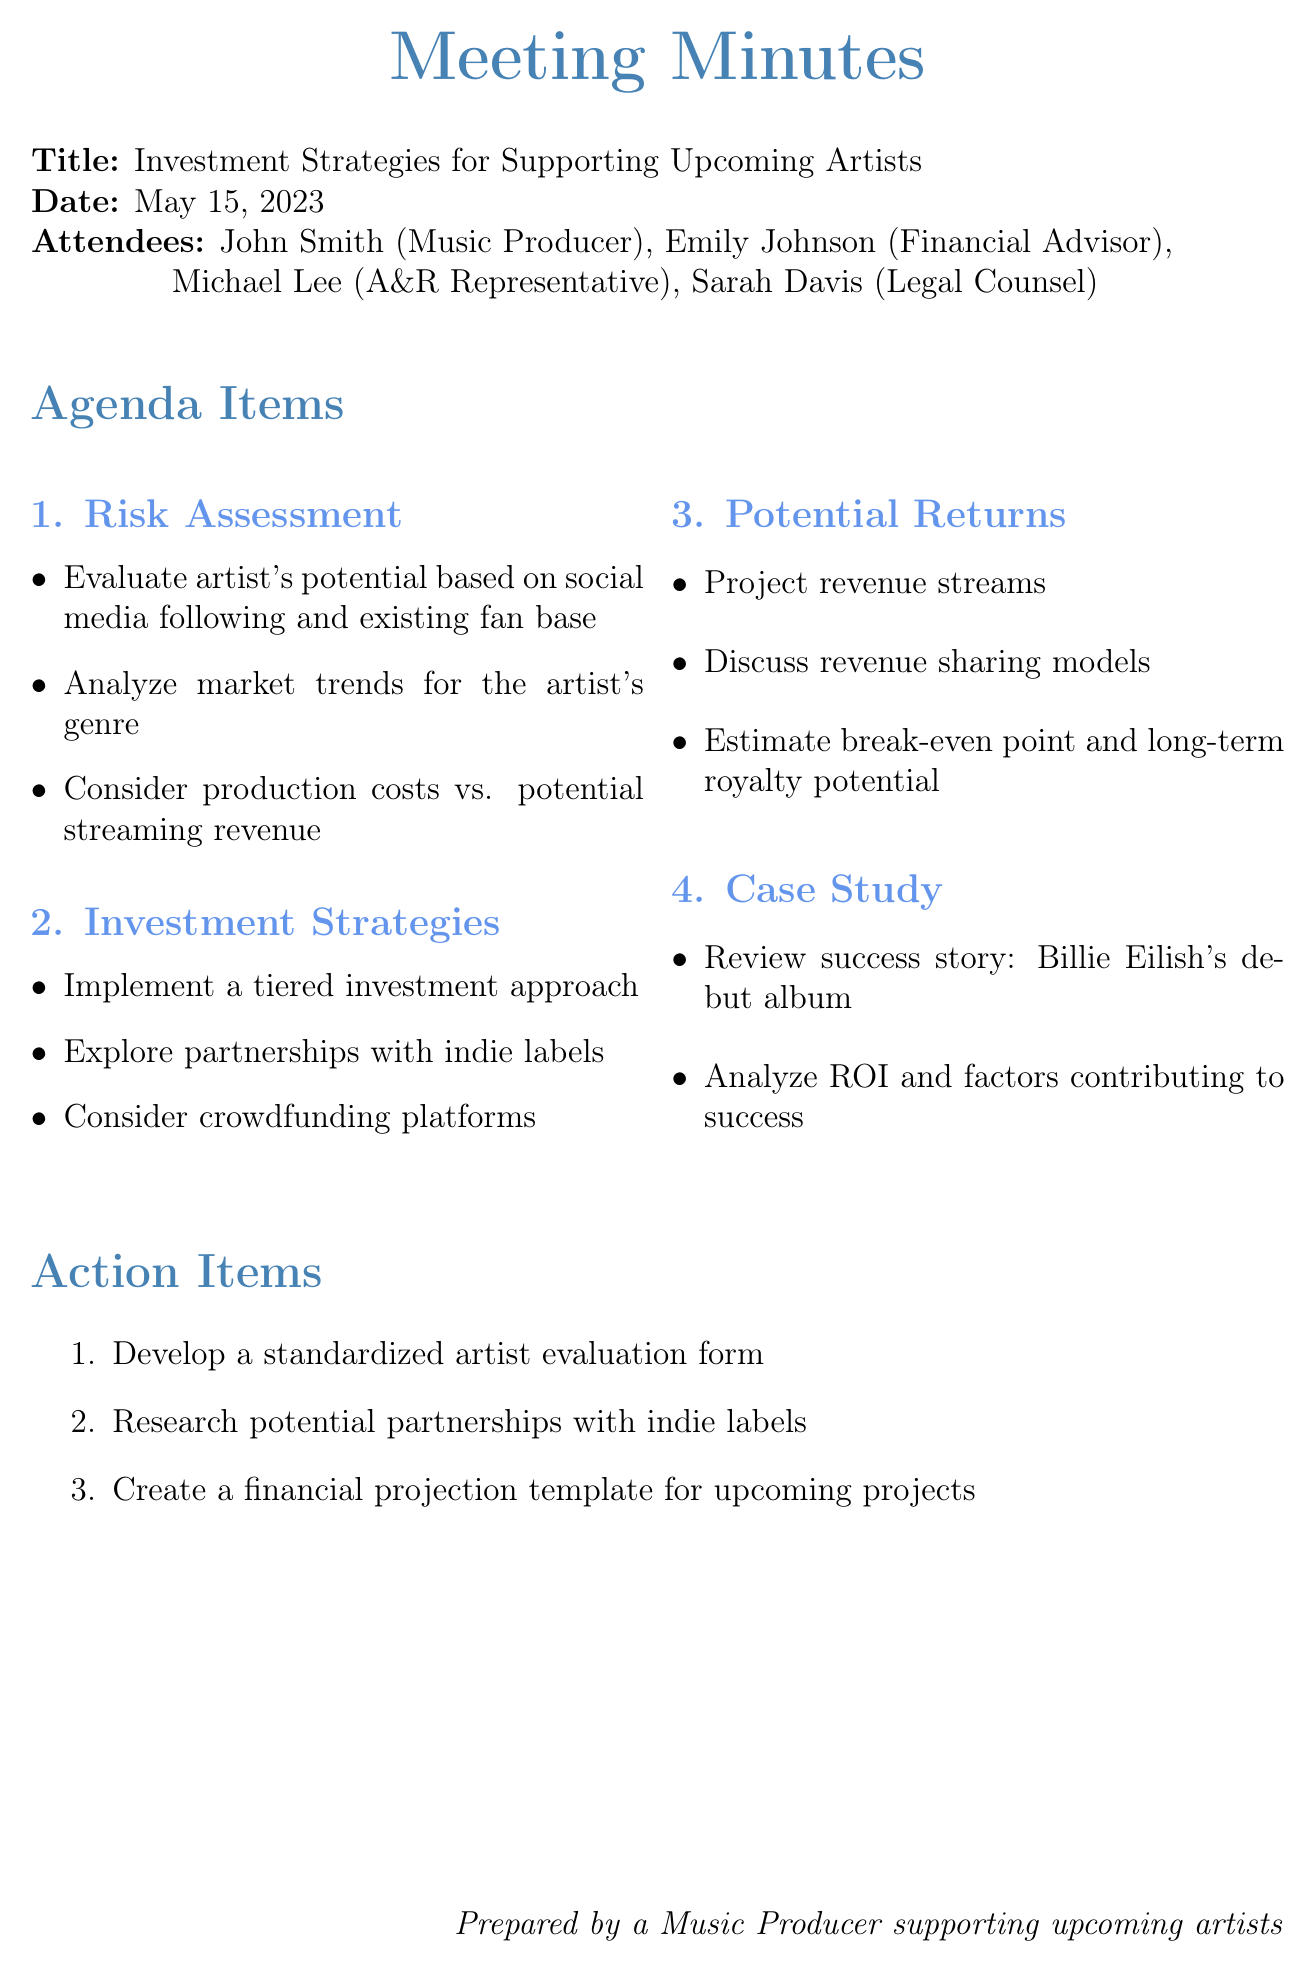What is the meeting title? The meeting title is explicitly stated at the beginning of the document.
Answer: Investment Strategies for Supporting Upcoming Artists Who is the financial advisor attending the meeting? The attendees list includes the names and roles of each participant, including the financial advisor.
Answer: Emily Johnson What date was the meeting held? The date is mentioned directly in the document, making it easy to locate.
Answer: May 15, 2023 What is one method to assess risk mentioned in the document? The key points under the risk assessment section provide specific methods for evaluating risk.
Answer: Social media following What are the revenue streams projected in the potential returns section? The document lists various revenue sources to be considered under potential returns.
Answer: Streaming, merchandise sales, live performances, sync licensing What action item involves artist evaluation? The action items outline specific tasks that need to be undertaken following the meeting, including one related to artist evaluation.
Answer: Develop a standardized artist evaluation form What is one investment strategy discussed regarding indie labels? The investment strategies section includes details on approaches related to partnerships with indie labels.
Answer: Explore partnerships with indie labels What was reviewed in the case study section? The case study section highlights a particular success story that is meant to serve as an example.
Answer: Investment in Billie Eilish's debut album What approach is suggested for investment based on artist experience? The investment strategies include guidance on how to invest relative to the artist's background and market standing.
Answer: Tiered investment approach 